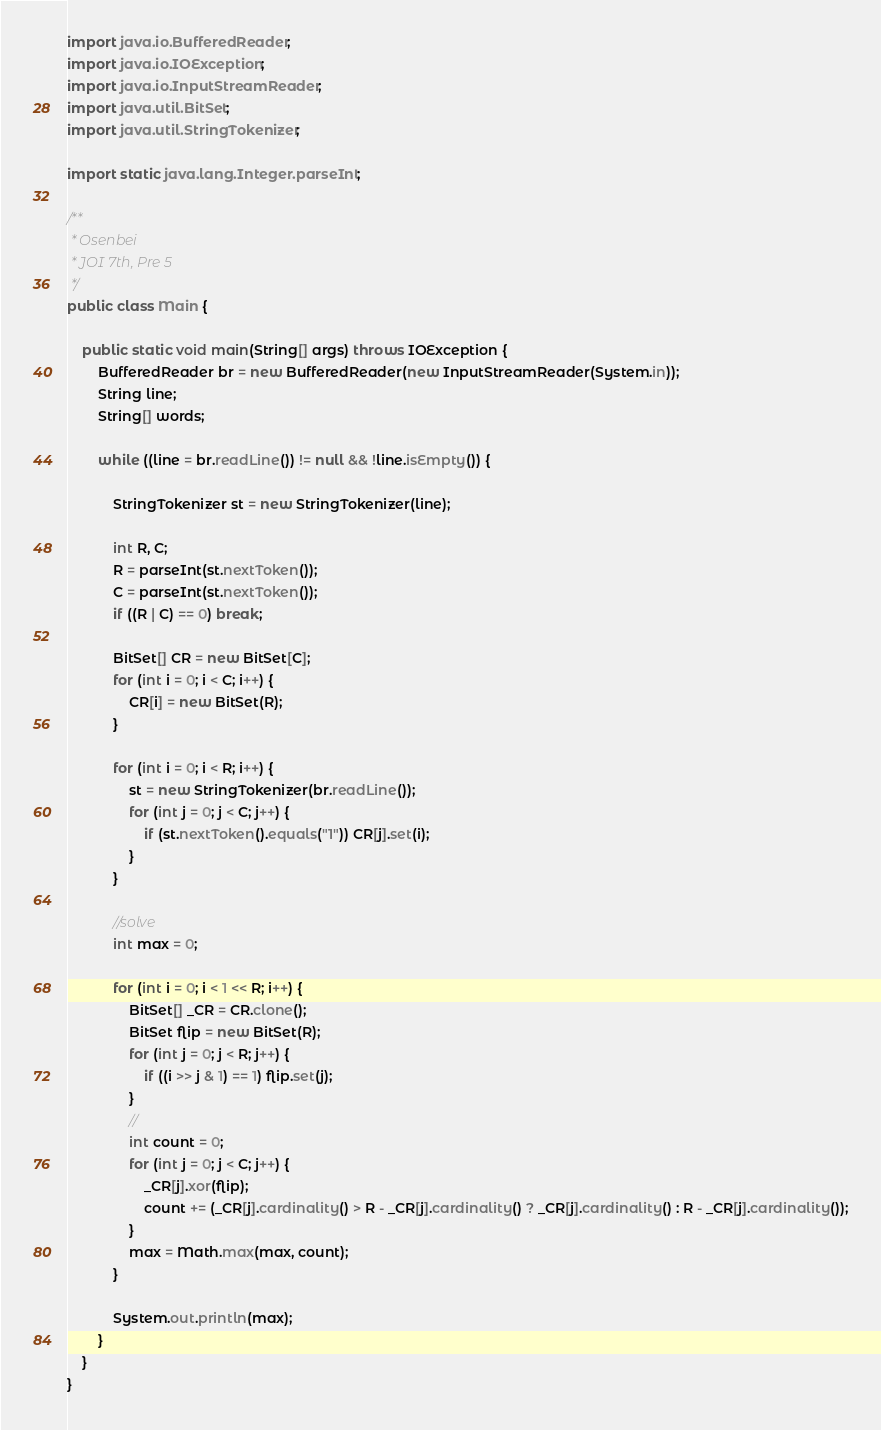Convert code to text. <code><loc_0><loc_0><loc_500><loc_500><_Java_>import java.io.BufferedReader;
import java.io.IOException;
import java.io.InputStreamReader;
import java.util.BitSet;
import java.util.StringTokenizer;

import static java.lang.Integer.parseInt;

/**
 * Osenbei
 * JOI 7th, Pre 5
 */
public class Main {

	public static void main(String[] args) throws IOException {
		BufferedReader br = new BufferedReader(new InputStreamReader(System.in));
		String line;
		String[] words;

		while ((line = br.readLine()) != null && !line.isEmpty()) {

			StringTokenizer st = new StringTokenizer(line);

			int R, C;
			R = parseInt(st.nextToken());
			C = parseInt(st.nextToken());
			if ((R | C) == 0) break;

			BitSet[] CR = new BitSet[C];
			for (int i = 0; i < C; i++) {
				CR[i] = new BitSet(R);
			}

			for (int i = 0; i < R; i++) {
				st = new StringTokenizer(br.readLine());
				for (int j = 0; j < C; j++) {
					if (st.nextToken().equals("1")) CR[j].set(i);
				}
			}

			//solve
			int max = 0;

			for (int i = 0; i < 1 << R; i++) {
				BitSet[] _CR = CR.clone();
				BitSet flip = new BitSet(R);
				for (int j = 0; j < R; j++) {
					if ((i >> j & 1) == 1) flip.set(j);
				}
				//
				int count = 0;
				for (int j = 0; j < C; j++) {
					_CR[j].xor(flip);
					count += (_CR[j].cardinality() > R - _CR[j].cardinality() ? _CR[j].cardinality() : R - _CR[j].cardinality());
				}
				max = Math.max(max, count);
			}

			System.out.println(max);
		}
	}
}</code> 